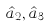Convert formula to latex. <formula><loc_0><loc_0><loc_500><loc_500>\hat { a } _ { 2 } , \hat { a } _ { 3 }</formula> 